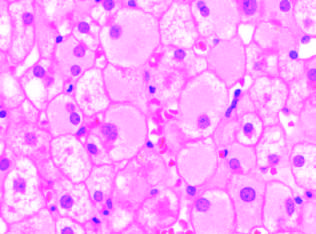do those with tumors that had mycn amplification show diffuse granular cyto-plasm, reflecting accumulated hepatitis b surface antigen hbsag in chronic infections?
Answer the question using a single word or phrase. No 